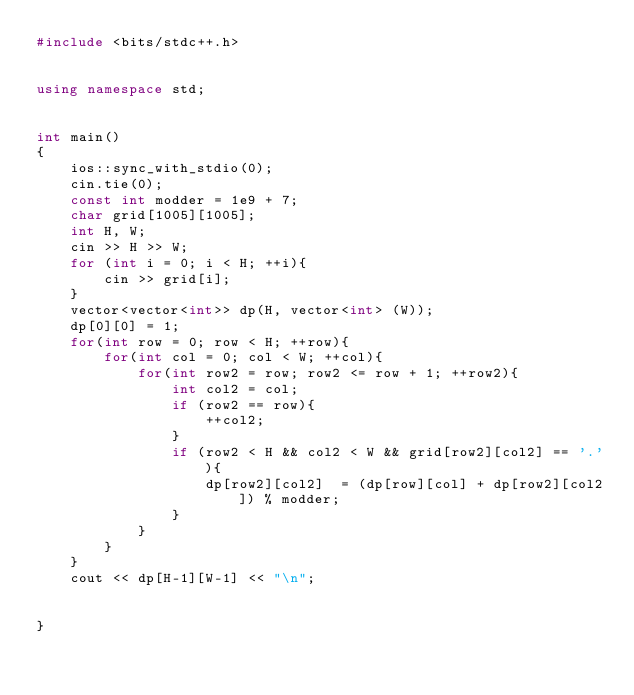<code> <loc_0><loc_0><loc_500><loc_500><_C++_>#include <bits/stdc++.h>


using namespace std;


int main()
{
    ios::sync_with_stdio(0);
    cin.tie(0);
    const int modder = 1e9 + 7;
    char grid[1005][1005];
    int H, W;
    cin >> H >> W;
    for (int i = 0; i < H; ++i){
        cin >> grid[i];
    }
    vector<vector<int>> dp(H, vector<int> (W));
    dp[0][0] = 1;
    for(int row = 0; row < H; ++row){
        for(int col = 0; col < W; ++col){
            for(int row2 = row; row2 <= row + 1; ++row2){
                int col2 = col;
                if (row2 == row){
                    ++col2;
                }
                if (row2 < H && col2 < W && grid[row2][col2] == '.'){
                    dp[row2][col2]  = (dp[row][col] + dp[row2][col2]) % modder;
                }
            }
        }
    }
    cout << dp[H-1][W-1] << "\n";


}
</code> 